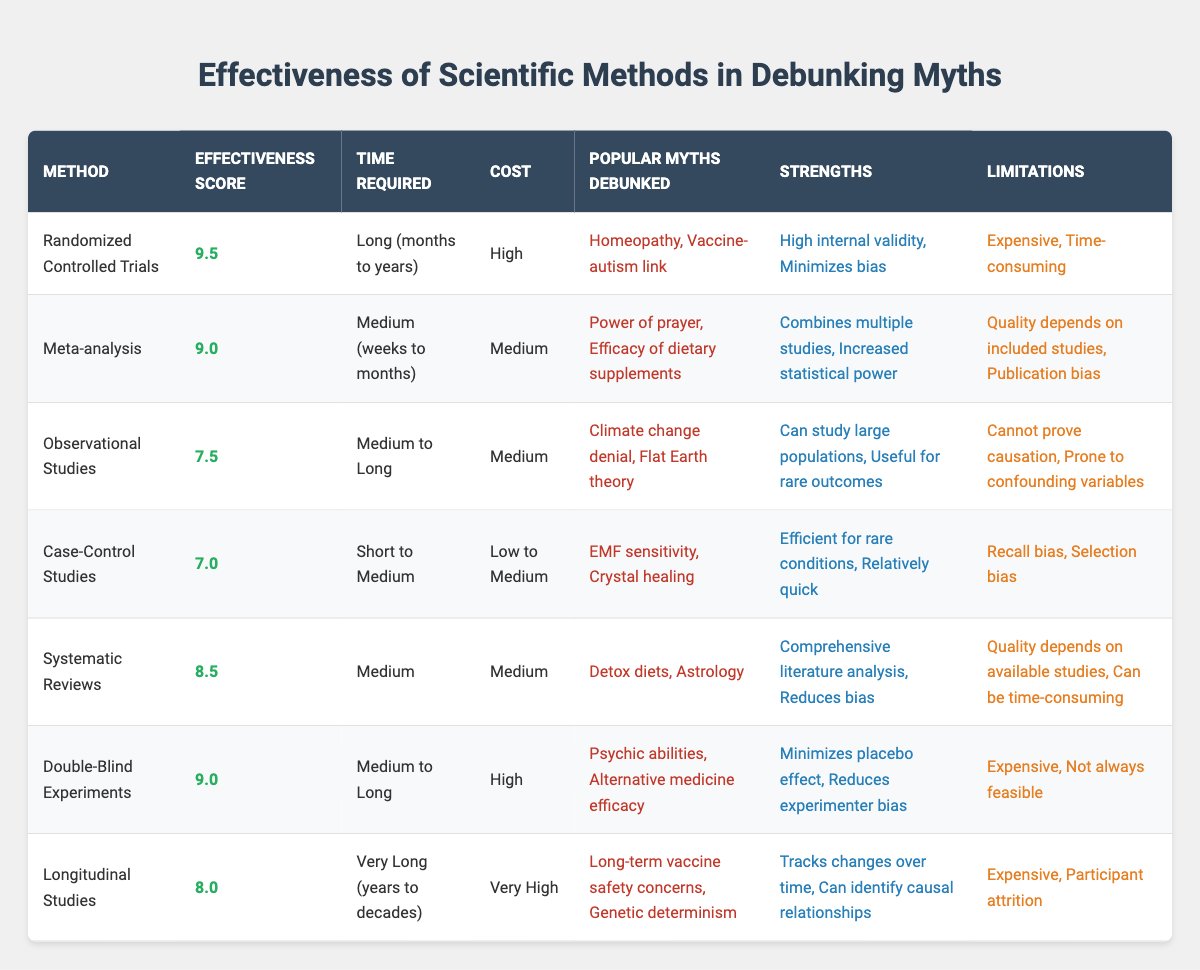What is the effectiveness score of Randomized Controlled Trials? The effectiveness score for Randomized Controlled Trials is found in the corresponding row under the "Effectiveness Score" column, which is listed as 9.5.
Answer: 9.5 Which method has the highest effectiveness score? By comparing the effectiveness scores listed for each method, Randomized Controlled Trials has the highest score of 9.5.
Answer: Randomized Controlled Trials How many popular myths were debunked by Double-Blind Experiments? Looking at the "Popular Myths Debunked" column for Double-Blind Experiments, it lists two myths: Psychic abilities and Alternative medicine efficacy. Thus, it debunked two myths.
Answer: 2 What method requires the longest time to conduct? From the "Time Required" column, Longitudinal Studies have the designation "Very Long (years to decades)," indicating it requires the longest duration compared to other methods.
Answer: Longitudinal Studies Are Randomized Controlled Trials considered expensive? Yes, looking at the "Cost" column for Randomized Controlled Trials, it is classified as "High," indicating that it is indeed costly.
Answer: Yes What is the average effectiveness score of methods that debunk myths regarding alternative medicine? The methods debunking myths related to alternative medicine are Double-Blind Experiments (9.0) and Randomized Controlled Trials (9.5). Calculating the average of these two scores gives (9.0 + 9.5) / 2 = 9.25.
Answer: 9.25 Which method is associated with debunking climate change denial? Observational Studies tackle climate change denial, as seen in the "Popular Myths Debunked" column.
Answer: Observational Studies Which two methods have similar effectiveness scores of 8.0 or higher? By reviewing the effectiveness scores, we observe that Randomized Controlled Trials (9.5), Double-Blind Experiments (9.0), Meta-analysis (9.0), Systematic Reviews (8.5), and Longitudinal Studies (8.0) all meet the criterion, thus yielding five applicable methods.
Answer: Five methods Can Case-Control Studies effectively prove causation? According to the "Limitations" column for Case-Control Studies, it states "Cannot prove causation," meaning these methods aren't appropriate for establishing causal relationships.
Answer: No What costs less, Case-Control Studies or Observational Studies? By comparing the "Cost" column, Case-Control Studies are categorized as "Low to Medium," while Observational Studies are listed as "Medium." Thus, Case-Control Studies generally incur lower costs.
Answer: Case-Control Studies 